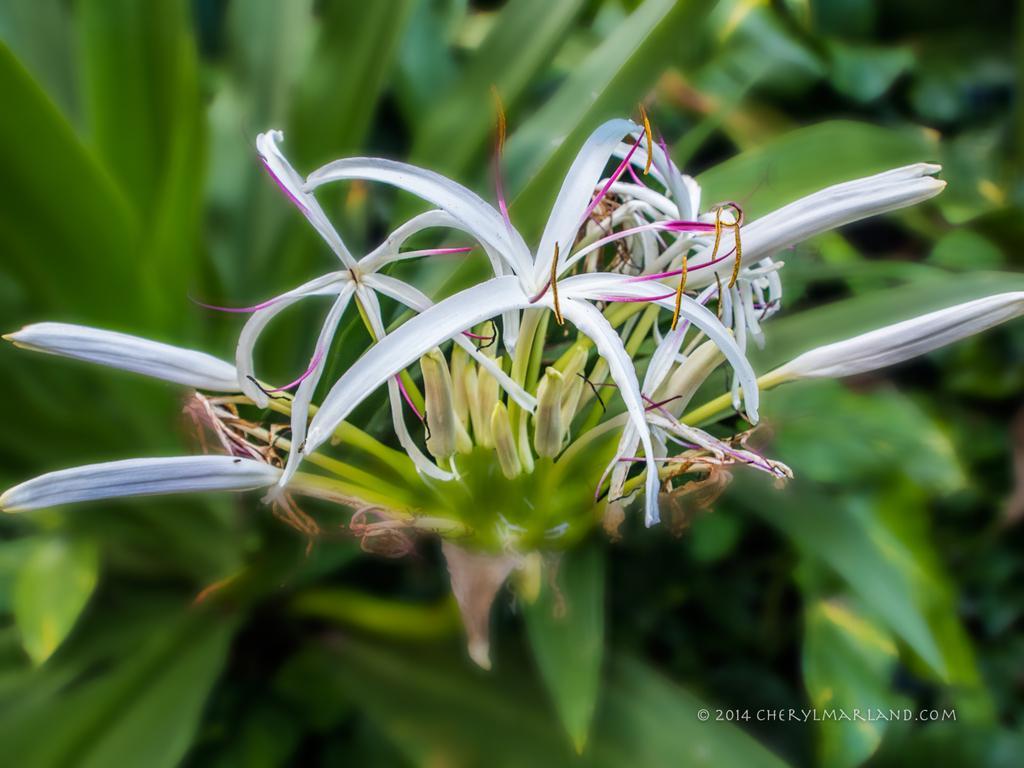Describe this image in one or two sentences. In the center of the image we can see flowers. At the bottom there are plants. 